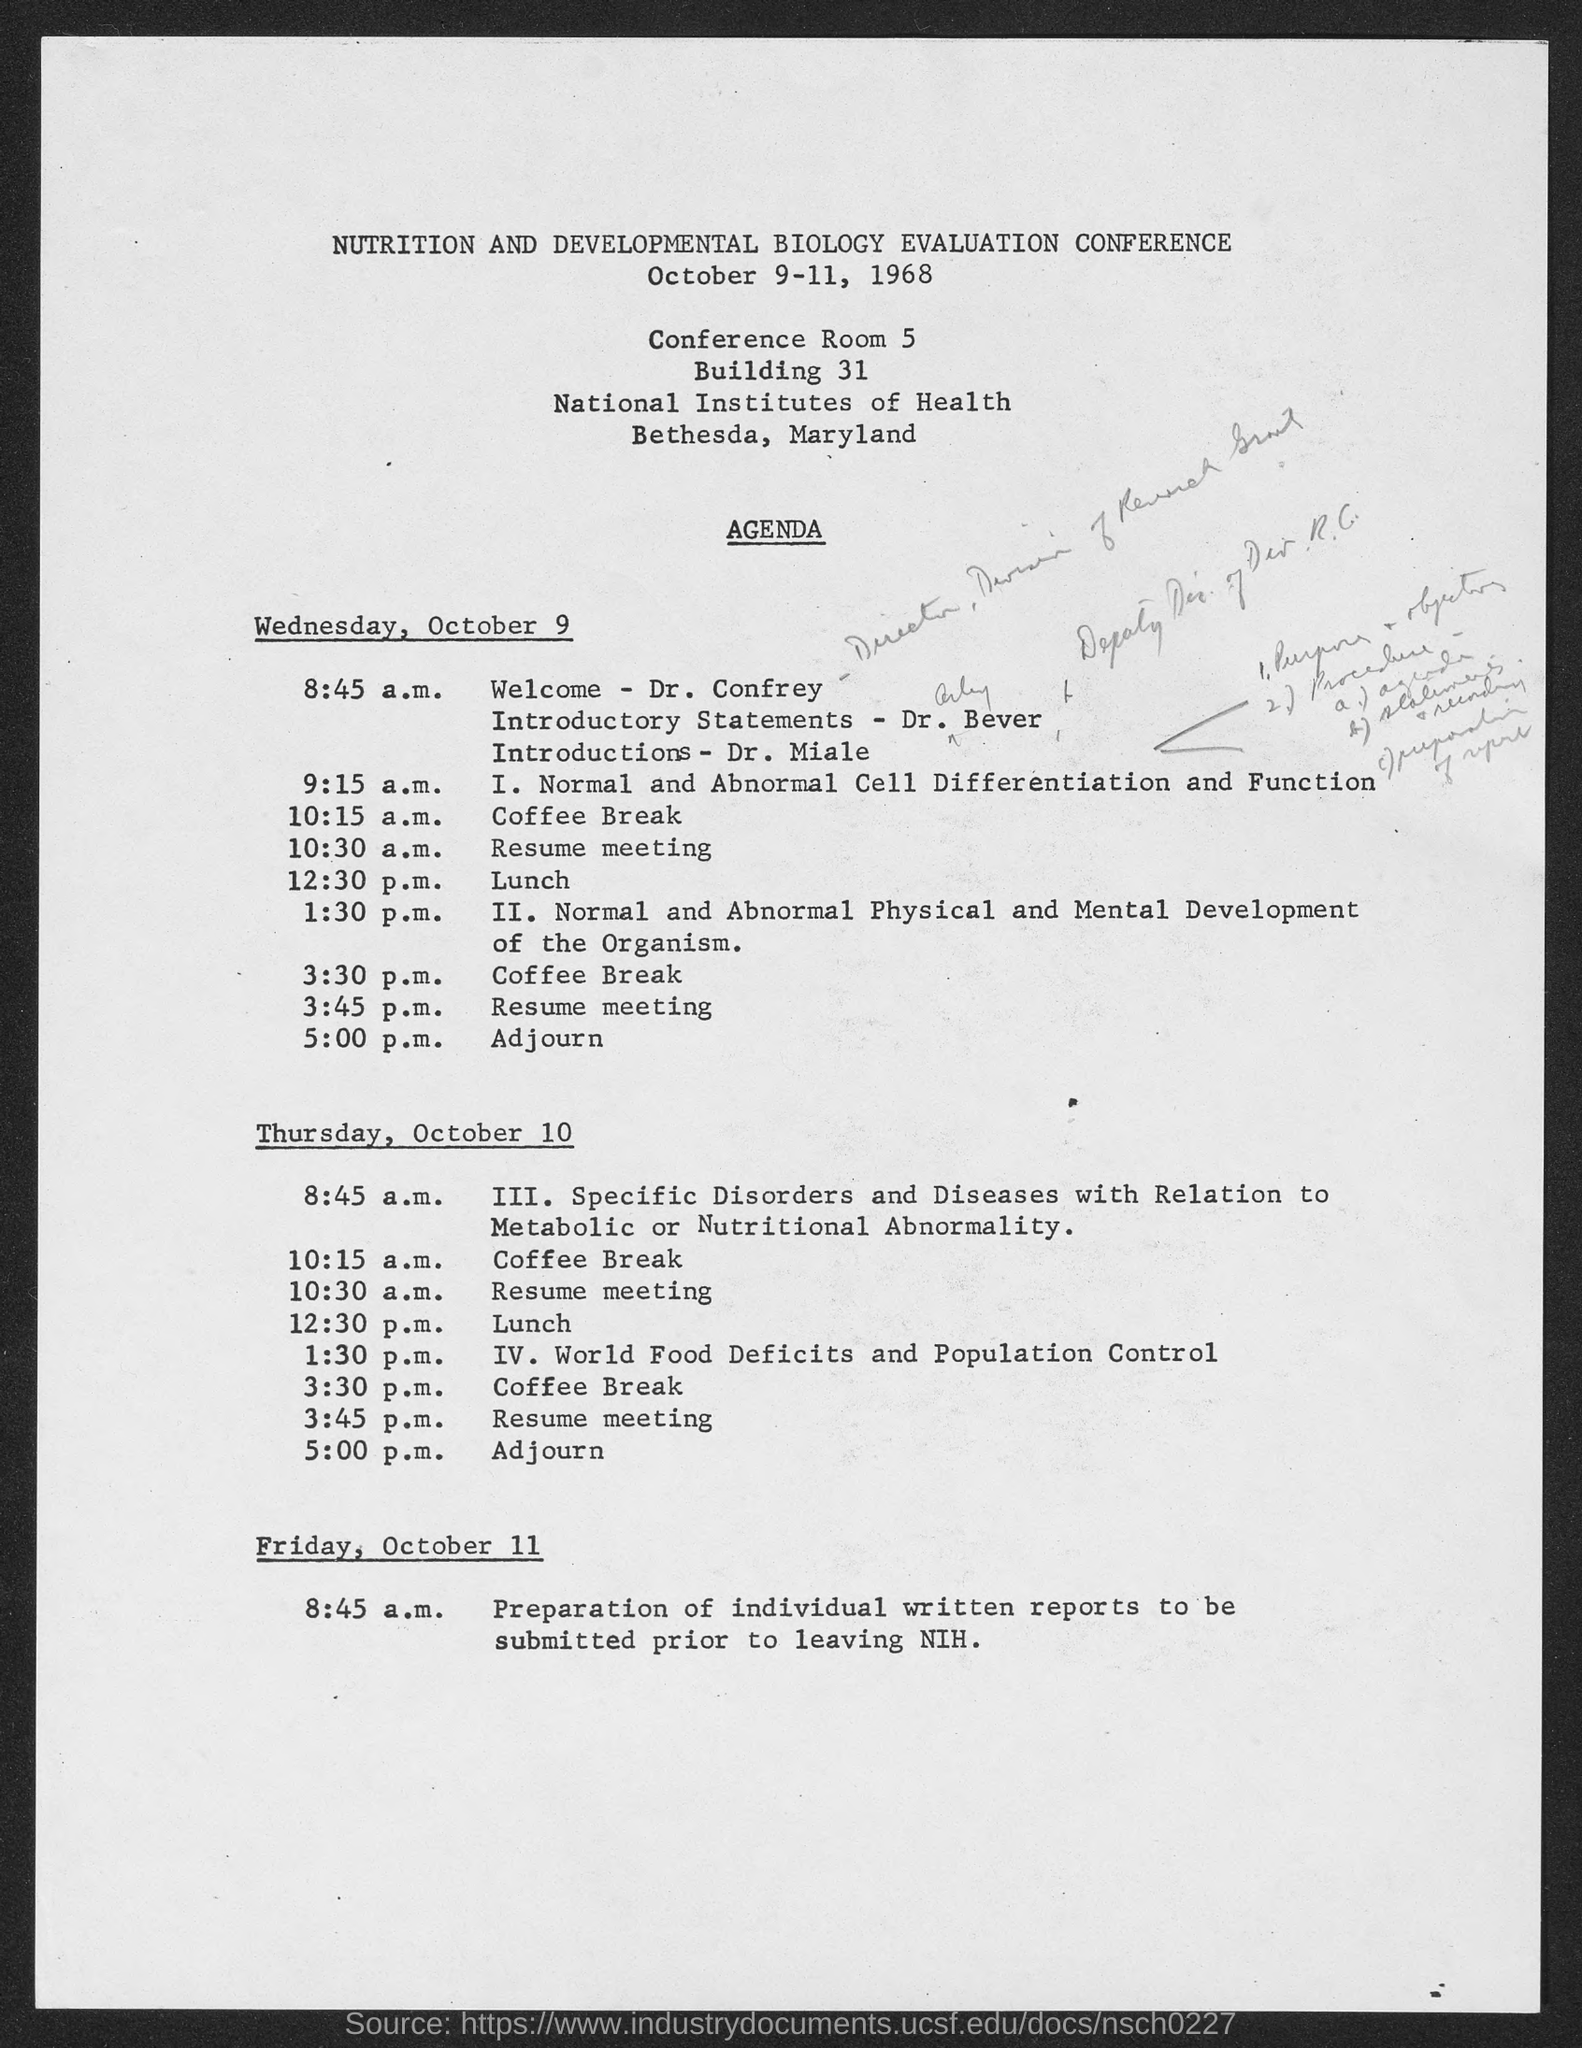When is the Nutrition and Developmental Biology Evaluation Conference held?
Your answer should be very brief. October 9-11, 1968. Who is giving the welcoming address for the session?
Provide a short and direct response. Dr. Confrey. Which session is carried out at 1:30 p.m. on Thursday, October 10?
Your answer should be very brief. IV. World Food Deficits and Population Control. Which session is carried out at 9:15 a.m. on Wednesday, October 9?
Your response must be concise. I. Normal and Abnormal Cell Differentiation and Function. 